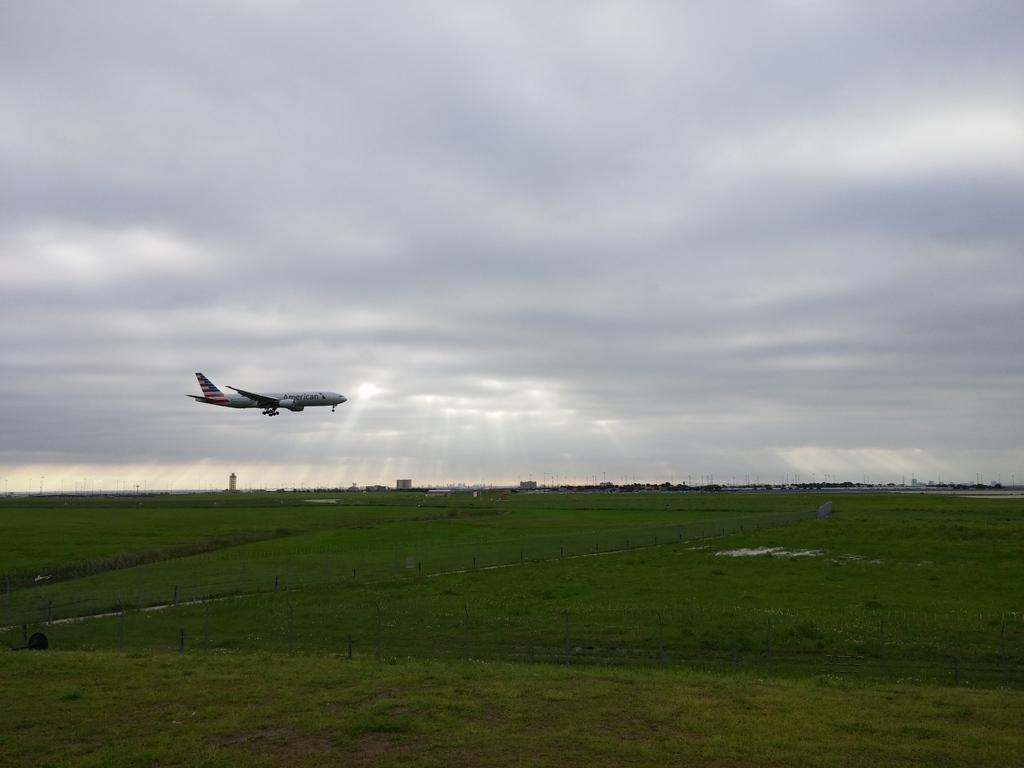What is the main subject of the image? The main subject of the image is an airplane. What is the airplane doing in the image? The airplane is flying. What type of terrain can be seen in the image? There is grass visible in the image. What can be seen in the distance in the image? There are buildings and trees in the background of the image. What is visible above the airplane in the image? The sky is visible in the image. Can you tell me how many bombs are being dropped from the airplane in the image? There are no bombs visible in the image; the airplane is simply flying. What type of car can be seen driving through the grass in the image? There is no car present in the image; it only features an airplane flying over grass. 